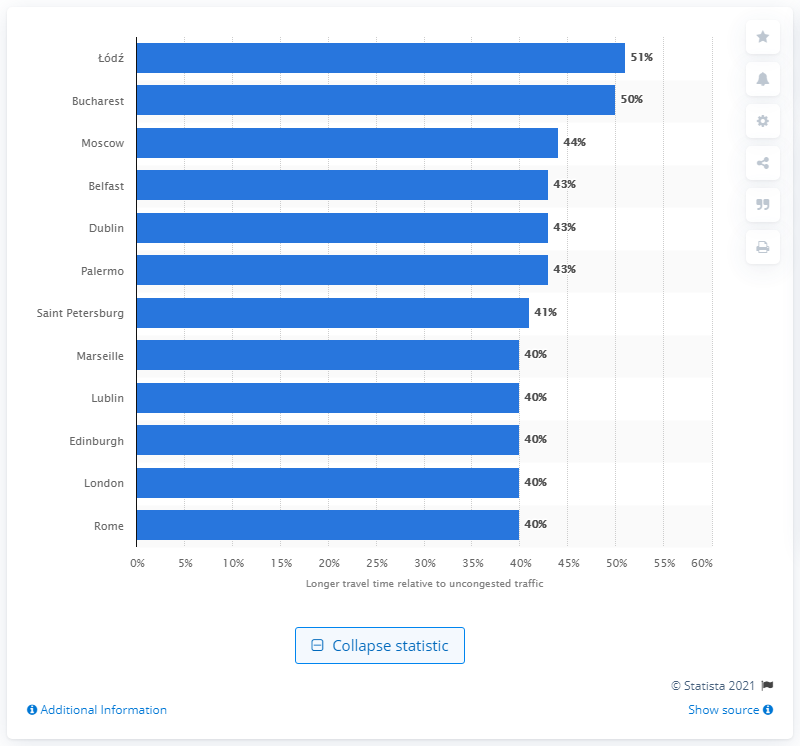Point out several critical features in this image. Bucharest was the second most congested city in Europe in 2018. 